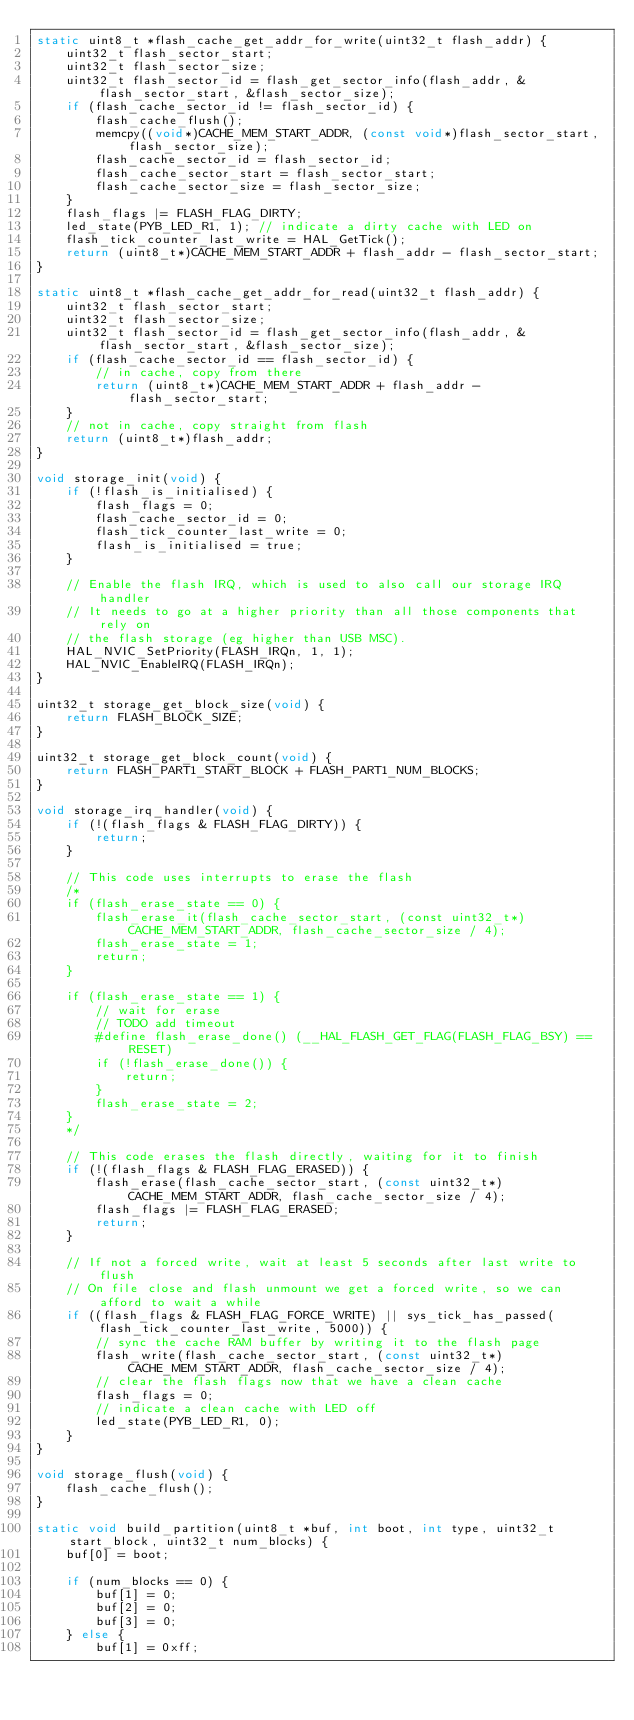<code> <loc_0><loc_0><loc_500><loc_500><_C_>static uint8_t *flash_cache_get_addr_for_write(uint32_t flash_addr) {
    uint32_t flash_sector_start;
    uint32_t flash_sector_size;
    uint32_t flash_sector_id = flash_get_sector_info(flash_addr, &flash_sector_start, &flash_sector_size);
    if (flash_cache_sector_id != flash_sector_id) {
        flash_cache_flush();
        memcpy((void*)CACHE_MEM_START_ADDR, (const void*)flash_sector_start, flash_sector_size);
        flash_cache_sector_id = flash_sector_id;
        flash_cache_sector_start = flash_sector_start;
        flash_cache_sector_size = flash_sector_size;
    }
    flash_flags |= FLASH_FLAG_DIRTY;
    led_state(PYB_LED_R1, 1); // indicate a dirty cache with LED on
    flash_tick_counter_last_write = HAL_GetTick();
    return (uint8_t*)CACHE_MEM_START_ADDR + flash_addr - flash_sector_start;
}

static uint8_t *flash_cache_get_addr_for_read(uint32_t flash_addr) {
    uint32_t flash_sector_start;
    uint32_t flash_sector_size;
    uint32_t flash_sector_id = flash_get_sector_info(flash_addr, &flash_sector_start, &flash_sector_size);
    if (flash_cache_sector_id == flash_sector_id) {
        // in cache, copy from there
        return (uint8_t*)CACHE_MEM_START_ADDR + flash_addr - flash_sector_start;
    }
    // not in cache, copy straight from flash
    return (uint8_t*)flash_addr;
}

void storage_init(void) {
    if (!flash_is_initialised) {
        flash_flags = 0;
        flash_cache_sector_id = 0;
        flash_tick_counter_last_write = 0;
        flash_is_initialised = true;
    }

    // Enable the flash IRQ, which is used to also call our storage IRQ handler
    // It needs to go at a higher priority than all those components that rely on
    // the flash storage (eg higher than USB MSC).
    HAL_NVIC_SetPriority(FLASH_IRQn, 1, 1);
    HAL_NVIC_EnableIRQ(FLASH_IRQn);
}

uint32_t storage_get_block_size(void) {
    return FLASH_BLOCK_SIZE;
}

uint32_t storage_get_block_count(void) {
    return FLASH_PART1_START_BLOCK + FLASH_PART1_NUM_BLOCKS;
}

void storage_irq_handler(void) {
    if (!(flash_flags & FLASH_FLAG_DIRTY)) {
        return;
    }

    // This code uses interrupts to erase the flash
    /*
    if (flash_erase_state == 0) {
        flash_erase_it(flash_cache_sector_start, (const uint32_t*)CACHE_MEM_START_ADDR, flash_cache_sector_size / 4);
        flash_erase_state = 1;
        return;
    }

    if (flash_erase_state == 1) {
        // wait for erase
        // TODO add timeout
        #define flash_erase_done() (__HAL_FLASH_GET_FLAG(FLASH_FLAG_BSY) == RESET)
        if (!flash_erase_done()) {
            return;
        }
        flash_erase_state = 2;
    }
    */

    // This code erases the flash directly, waiting for it to finish
    if (!(flash_flags & FLASH_FLAG_ERASED)) {
        flash_erase(flash_cache_sector_start, (const uint32_t*)CACHE_MEM_START_ADDR, flash_cache_sector_size / 4);
        flash_flags |= FLASH_FLAG_ERASED;
        return;
    }

    // If not a forced write, wait at least 5 seconds after last write to flush
    // On file close and flash unmount we get a forced write, so we can afford to wait a while
    if ((flash_flags & FLASH_FLAG_FORCE_WRITE) || sys_tick_has_passed(flash_tick_counter_last_write, 5000)) {
        // sync the cache RAM buffer by writing it to the flash page
        flash_write(flash_cache_sector_start, (const uint32_t*)CACHE_MEM_START_ADDR, flash_cache_sector_size / 4);
        // clear the flash flags now that we have a clean cache
        flash_flags = 0;
        // indicate a clean cache with LED off
        led_state(PYB_LED_R1, 0);
    }
}

void storage_flush(void) {
    flash_cache_flush();
}

static void build_partition(uint8_t *buf, int boot, int type, uint32_t start_block, uint32_t num_blocks) {
    buf[0] = boot;

    if (num_blocks == 0) {
        buf[1] = 0;
        buf[2] = 0;
        buf[3] = 0;
    } else {
        buf[1] = 0xff;</code> 